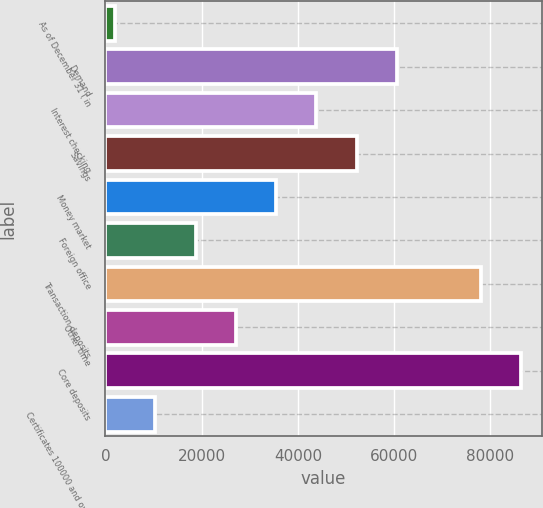Convert chart to OTSL. <chart><loc_0><loc_0><loc_500><loc_500><bar_chart><fcel>As of December 31 ( in<fcel>Demand<fcel>Interest checking<fcel>Savings<fcel>Money market<fcel>Foreign office<fcel>Transaction deposits<fcel>Other time<fcel>Core deposits<fcel>Certificates 100000 and over<nl><fcel>2011<fcel>60600.3<fcel>43860.5<fcel>52230.4<fcel>35490.6<fcel>18750.8<fcel>77987<fcel>27120.7<fcel>86356.9<fcel>10380.9<nl></chart> 